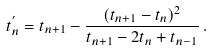<formula> <loc_0><loc_0><loc_500><loc_500>t _ { n } ^ { ^ { \prime } } = t _ { n + 1 } - \frac { ( t _ { n + 1 } - t _ { n } ) ^ { 2 } } { t _ { n + 1 } - 2 t _ { n } + t _ { n - 1 } } \, .</formula> 